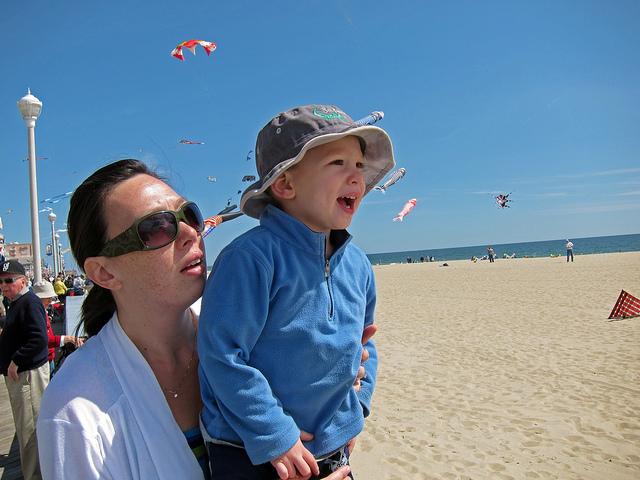What is in the women's right hand?
Short answer required. Child. Who took this picture?
Keep it brief. Father. Is the baby a boy or a girl?
Concise answer only. Boy. What animal do the closest kites resemble?
Quick response, please. Bird. Is the boy trying to fly his kite?
Short answer required. No. Is the woman carrying the boy?
Quick response, please. Yes. Was this photo taken in a zoo?
Be succinct. No. Does the girl have a big nose?
Quick response, please. No. What is the woman doing?
Answer briefly. Holding boy. Where is she sitting?
Concise answer only. Beach. Is this a winter scene?
Quick response, please. No. What is written on the boy's jacket?
Write a very short answer. Nothing. Does this little boy look happy?
Be succinct. Yes. Where are the people wearing glasses?
Write a very short answer. Beach. Where are the people located?
Quick response, please. Beach. Is the man wearing a white hat?
Concise answer only. No. What is the boy doing?
Write a very short answer. Watching. Are these people flying kites at the beach?
Be succinct. No. Is it sunny outside?
Answer briefly. Yes. 